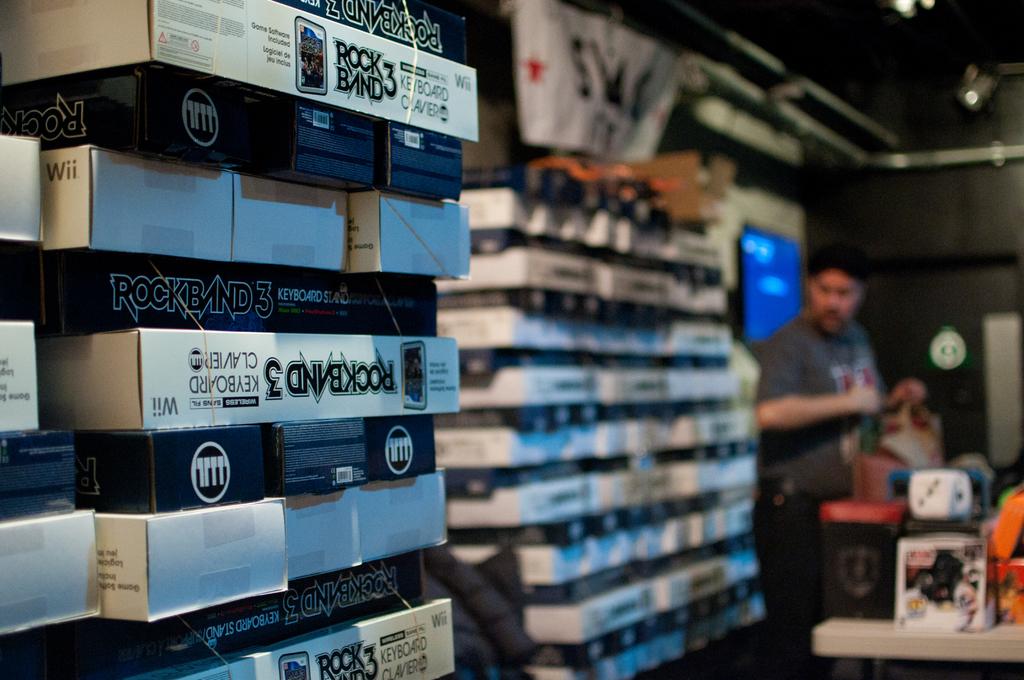What is in the boxes?
Make the answer very short. Rock band 3. 